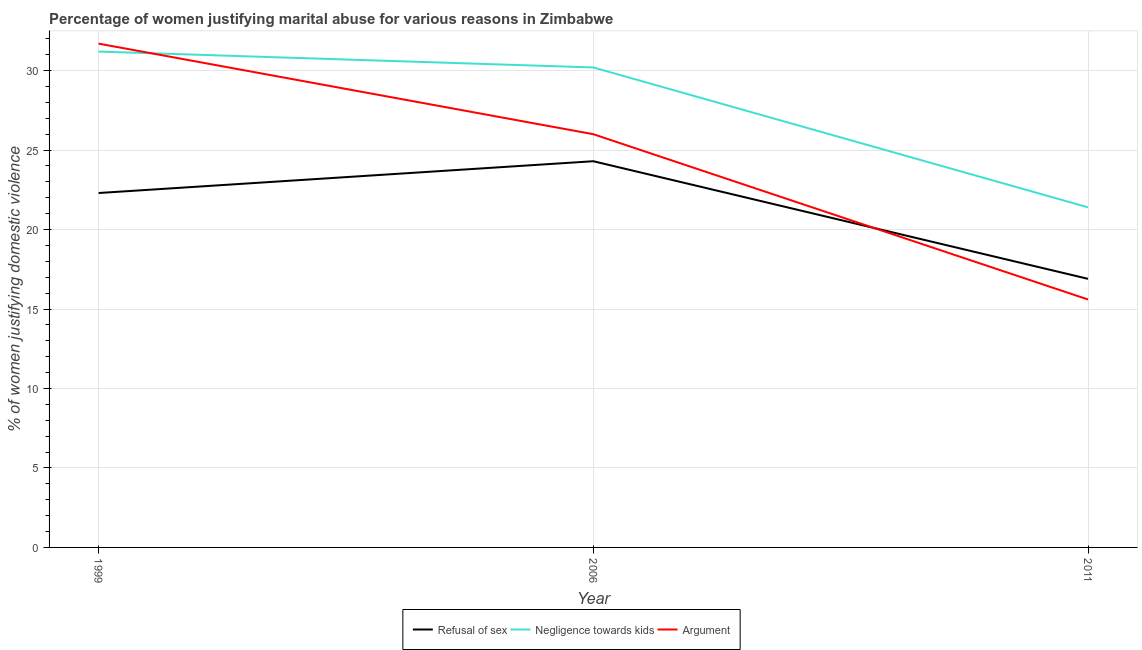Does the line corresponding to percentage of women justifying domestic violence due to refusal of sex intersect with the line corresponding to percentage of women justifying domestic violence due to arguments?
Keep it short and to the point. Yes. Is the number of lines equal to the number of legend labels?
Your answer should be very brief. Yes. What is the percentage of women justifying domestic violence due to negligence towards kids in 1999?
Provide a short and direct response. 31.2. Across all years, what is the maximum percentage of women justifying domestic violence due to arguments?
Your response must be concise. 31.7. Across all years, what is the minimum percentage of women justifying domestic violence due to negligence towards kids?
Ensure brevity in your answer.  21.4. In which year was the percentage of women justifying domestic violence due to negligence towards kids minimum?
Ensure brevity in your answer.  2011. What is the total percentage of women justifying domestic violence due to negligence towards kids in the graph?
Make the answer very short. 82.8. What is the difference between the percentage of women justifying domestic violence due to negligence towards kids in 2006 and that in 2011?
Your response must be concise. 8.8. What is the average percentage of women justifying domestic violence due to refusal of sex per year?
Offer a very short reply. 21.17. In the year 2011, what is the difference between the percentage of women justifying domestic violence due to refusal of sex and percentage of women justifying domestic violence due to negligence towards kids?
Give a very brief answer. -4.5. In how many years, is the percentage of women justifying domestic violence due to negligence towards kids greater than 10 %?
Your answer should be very brief. 3. What is the ratio of the percentage of women justifying domestic violence due to arguments in 2006 to that in 2011?
Provide a succinct answer. 1.67. What is the difference between the highest and the lowest percentage of women justifying domestic violence due to arguments?
Ensure brevity in your answer.  16.1. In how many years, is the percentage of women justifying domestic violence due to refusal of sex greater than the average percentage of women justifying domestic violence due to refusal of sex taken over all years?
Give a very brief answer. 2. Does the percentage of women justifying domestic violence due to negligence towards kids monotonically increase over the years?
Keep it short and to the point. No. Is the percentage of women justifying domestic violence due to refusal of sex strictly greater than the percentage of women justifying domestic violence due to negligence towards kids over the years?
Your response must be concise. No. How many legend labels are there?
Your response must be concise. 3. What is the title of the graph?
Keep it short and to the point. Percentage of women justifying marital abuse for various reasons in Zimbabwe. What is the label or title of the Y-axis?
Offer a terse response. % of women justifying domestic violence. What is the % of women justifying domestic violence of Refusal of sex in 1999?
Give a very brief answer. 22.3. What is the % of women justifying domestic violence of Negligence towards kids in 1999?
Offer a terse response. 31.2. What is the % of women justifying domestic violence of Argument in 1999?
Offer a terse response. 31.7. What is the % of women justifying domestic violence in Refusal of sex in 2006?
Provide a succinct answer. 24.3. What is the % of women justifying domestic violence in Negligence towards kids in 2006?
Give a very brief answer. 30.2. What is the % of women justifying domestic violence in Negligence towards kids in 2011?
Offer a very short reply. 21.4. What is the % of women justifying domestic violence of Argument in 2011?
Offer a very short reply. 15.6. Across all years, what is the maximum % of women justifying domestic violence of Refusal of sex?
Ensure brevity in your answer.  24.3. Across all years, what is the maximum % of women justifying domestic violence in Negligence towards kids?
Provide a succinct answer. 31.2. Across all years, what is the maximum % of women justifying domestic violence of Argument?
Provide a short and direct response. 31.7. Across all years, what is the minimum % of women justifying domestic violence of Negligence towards kids?
Your response must be concise. 21.4. Across all years, what is the minimum % of women justifying domestic violence in Argument?
Offer a very short reply. 15.6. What is the total % of women justifying domestic violence in Refusal of sex in the graph?
Your response must be concise. 63.5. What is the total % of women justifying domestic violence of Negligence towards kids in the graph?
Ensure brevity in your answer.  82.8. What is the total % of women justifying domestic violence in Argument in the graph?
Your response must be concise. 73.3. What is the difference between the % of women justifying domestic violence of Refusal of sex in 1999 and that in 2006?
Provide a short and direct response. -2. What is the difference between the % of women justifying domestic violence in Negligence towards kids in 1999 and that in 2006?
Make the answer very short. 1. What is the difference between the % of women justifying domestic violence of Argument in 1999 and that in 2006?
Provide a short and direct response. 5.7. What is the difference between the % of women justifying domestic violence in Refusal of sex in 1999 and that in 2011?
Your answer should be compact. 5.4. What is the difference between the % of women justifying domestic violence of Negligence towards kids in 1999 and that in 2011?
Your answer should be very brief. 9.8. What is the difference between the % of women justifying domestic violence in Argument in 1999 and that in 2011?
Offer a very short reply. 16.1. What is the difference between the % of women justifying domestic violence of Refusal of sex in 2006 and that in 2011?
Make the answer very short. 7.4. What is the difference between the % of women justifying domestic violence in Argument in 2006 and that in 2011?
Make the answer very short. 10.4. What is the difference between the % of women justifying domestic violence in Refusal of sex in 1999 and the % of women justifying domestic violence in Negligence towards kids in 2006?
Ensure brevity in your answer.  -7.9. What is the difference between the % of women justifying domestic violence in Refusal of sex in 1999 and the % of women justifying domestic violence in Argument in 2006?
Keep it short and to the point. -3.7. What is the difference between the % of women justifying domestic violence in Negligence towards kids in 1999 and the % of women justifying domestic violence in Argument in 2006?
Offer a very short reply. 5.2. What is the difference between the % of women justifying domestic violence in Refusal of sex in 1999 and the % of women justifying domestic violence in Negligence towards kids in 2011?
Offer a terse response. 0.9. What is the difference between the % of women justifying domestic violence of Negligence towards kids in 2006 and the % of women justifying domestic violence of Argument in 2011?
Keep it short and to the point. 14.6. What is the average % of women justifying domestic violence in Refusal of sex per year?
Provide a succinct answer. 21.17. What is the average % of women justifying domestic violence of Negligence towards kids per year?
Provide a succinct answer. 27.6. What is the average % of women justifying domestic violence in Argument per year?
Your answer should be very brief. 24.43. In the year 2006, what is the difference between the % of women justifying domestic violence of Refusal of sex and % of women justifying domestic violence of Negligence towards kids?
Your answer should be very brief. -5.9. In the year 2006, what is the difference between the % of women justifying domestic violence in Refusal of sex and % of women justifying domestic violence in Argument?
Ensure brevity in your answer.  -1.7. In the year 2006, what is the difference between the % of women justifying domestic violence of Negligence towards kids and % of women justifying domestic violence of Argument?
Keep it short and to the point. 4.2. In the year 2011, what is the difference between the % of women justifying domestic violence in Refusal of sex and % of women justifying domestic violence in Argument?
Your answer should be very brief. 1.3. In the year 2011, what is the difference between the % of women justifying domestic violence of Negligence towards kids and % of women justifying domestic violence of Argument?
Provide a short and direct response. 5.8. What is the ratio of the % of women justifying domestic violence in Refusal of sex in 1999 to that in 2006?
Your answer should be compact. 0.92. What is the ratio of the % of women justifying domestic violence in Negligence towards kids in 1999 to that in 2006?
Provide a short and direct response. 1.03. What is the ratio of the % of women justifying domestic violence in Argument in 1999 to that in 2006?
Offer a terse response. 1.22. What is the ratio of the % of women justifying domestic violence in Refusal of sex in 1999 to that in 2011?
Ensure brevity in your answer.  1.32. What is the ratio of the % of women justifying domestic violence in Negligence towards kids in 1999 to that in 2011?
Make the answer very short. 1.46. What is the ratio of the % of women justifying domestic violence of Argument in 1999 to that in 2011?
Offer a very short reply. 2.03. What is the ratio of the % of women justifying domestic violence in Refusal of sex in 2006 to that in 2011?
Offer a very short reply. 1.44. What is the ratio of the % of women justifying domestic violence of Negligence towards kids in 2006 to that in 2011?
Give a very brief answer. 1.41. What is the ratio of the % of women justifying domestic violence of Argument in 2006 to that in 2011?
Provide a short and direct response. 1.67. What is the difference between the highest and the second highest % of women justifying domestic violence of Negligence towards kids?
Offer a terse response. 1. What is the difference between the highest and the lowest % of women justifying domestic violence of Negligence towards kids?
Provide a succinct answer. 9.8. What is the difference between the highest and the lowest % of women justifying domestic violence in Argument?
Ensure brevity in your answer.  16.1. 